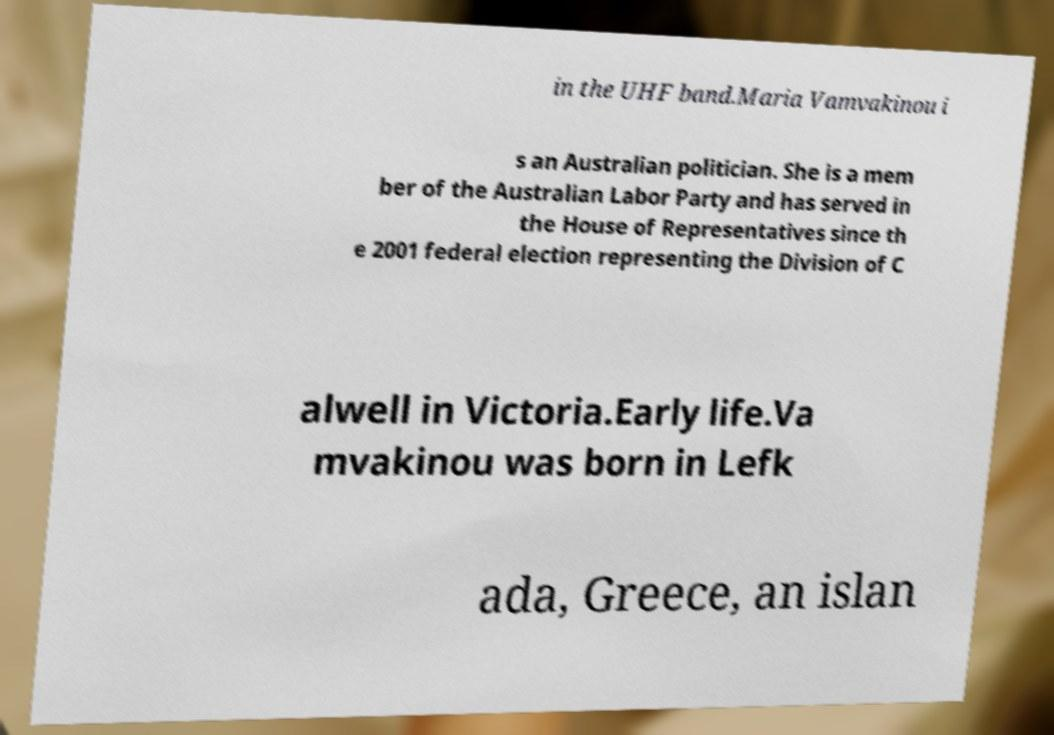Could you assist in decoding the text presented in this image and type it out clearly? in the UHF band.Maria Vamvakinou i s an Australian politician. She is a mem ber of the Australian Labor Party and has served in the House of Representatives since th e 2001 federal election representing the Division of C alwell in Victoria.Early life.Va mvakinou was born in Lefk ada, Greece, an islan 